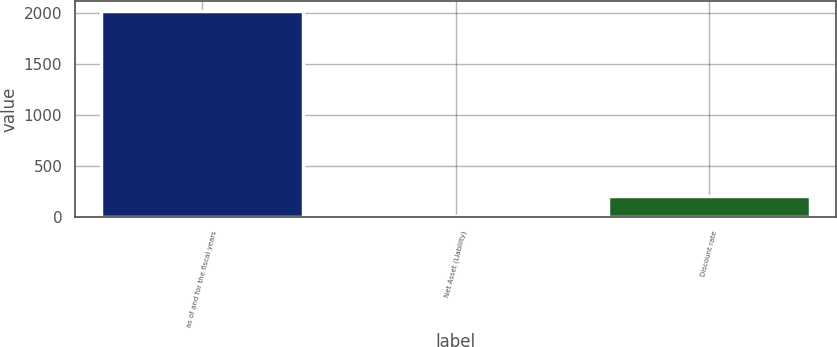Convert chart. <chart><loc_0><loc_0><loc_500><loc_500><bar_chart><fcel>as of and for the fiscal years<fcel>Net Asset (Liability)<fcel>Discount rate<nl><fcel>2014<fcel>0.9<fcel>202.21<nl></chart> 